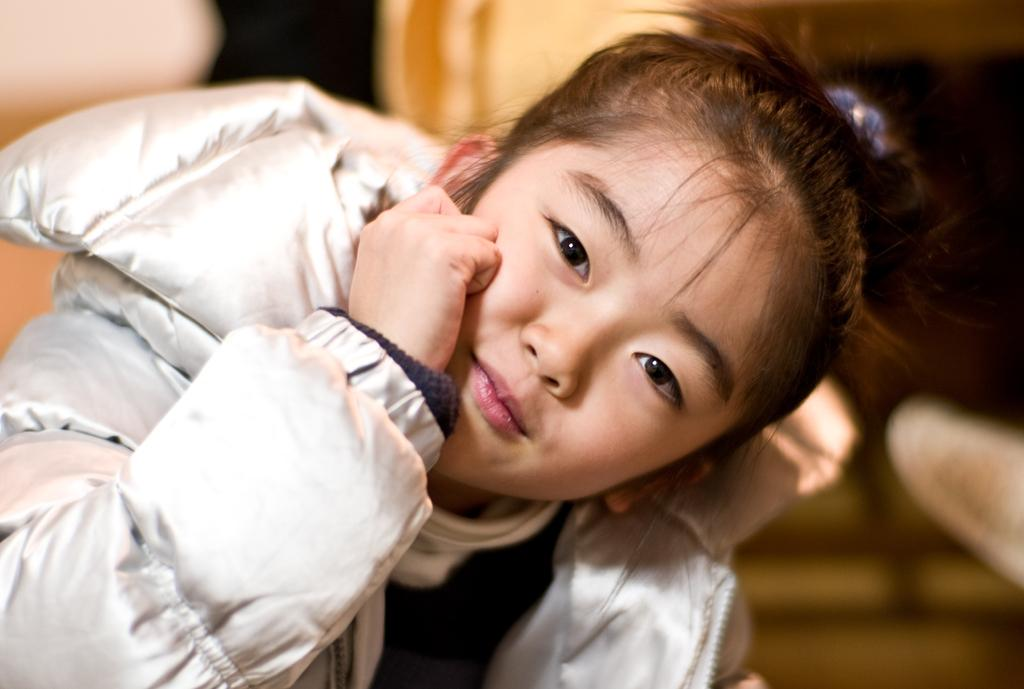Who is the main subject in the image? There is a girl in the image. What is the girl wearing? The girl is wearing a white jacket. What colors can be seen in the background of the image? The background of the image includes black and cream colors. What type of shirt is the girl thinking about in the image? There is no shirt or indication of the girl's thoughts in the image. What type of linen is visible in the image? There is no linen present in the image. 